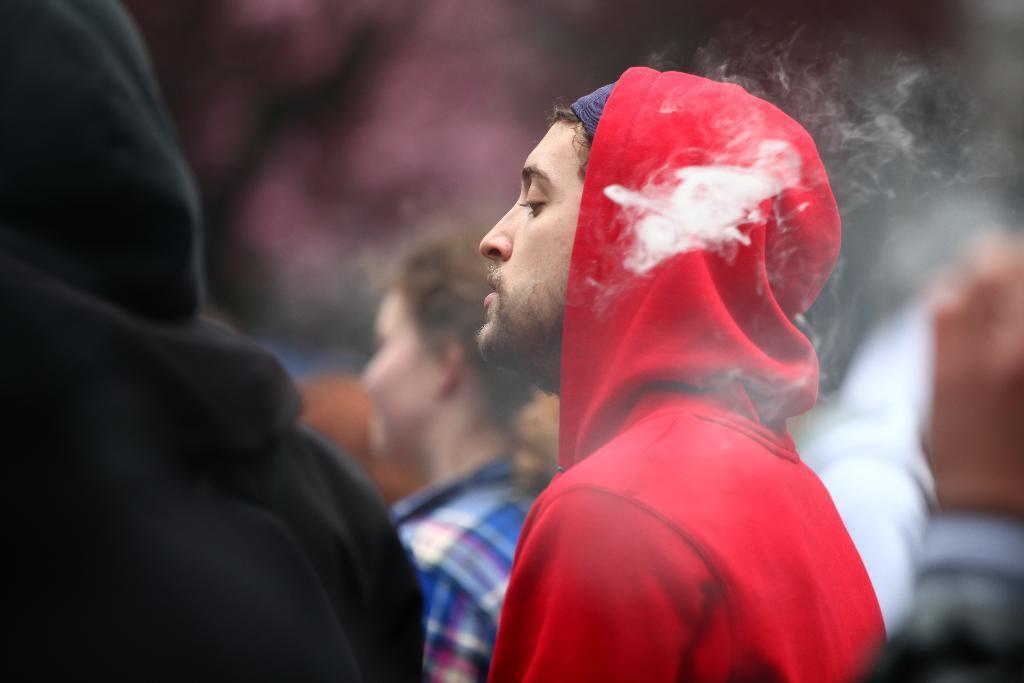How many people are in the image? There is a group of persons in the image. Where are the persons located in the image? The group of persons is located towards the bottom of the image. Can you describe any specific body part visible in the image? There is a person's hand visible in the image. On which side of the image is the hand located? The hand is located towards the right side of the image. How would you describe the background of the image? The background of the image is blurred. What type of notebook is the person holding in the image? There is no notebook present in the image. Can you tell me which page the person is reading from in the image? There is no page to read from in the image, as there is no book or notebook present. 